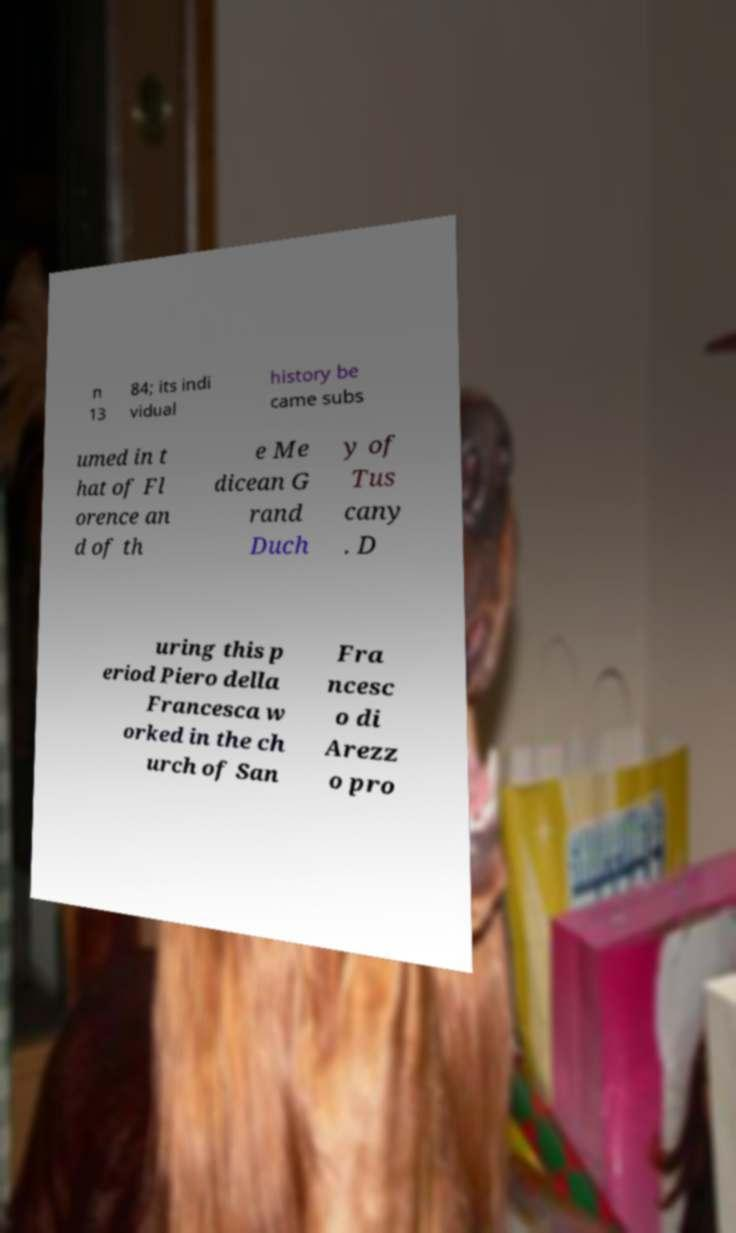Could you extract and type out the text from this image? n 13 84; its indi vidual history be came subs umed in t hat of Fl orence an d of th e Me dicean G rand Duch y of Tus cany . D uring this p eriod Piero della Francesca w orked in the ch urch of San Fra ncesc o di Arezz o pro 